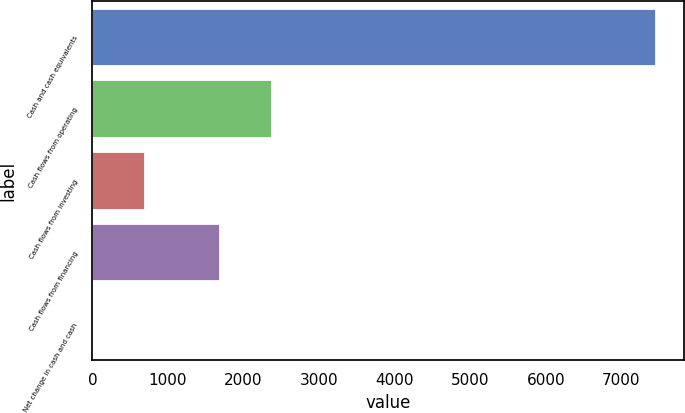Convert chart to OTSL. <chart><loc_0><loc_0><loc_500><loc_500><bar_chart><fcel>Cash and cash equivalents<fcel>Cash flows from operating<fcel>Cash flows from investing<fcel>Cash flows from financing<fcel>Net change in cash and cash<nl><fcel>7460.2<fcel>2373.6<fcel>696.6<fcel>1685<fcel>8<nl></chart> 